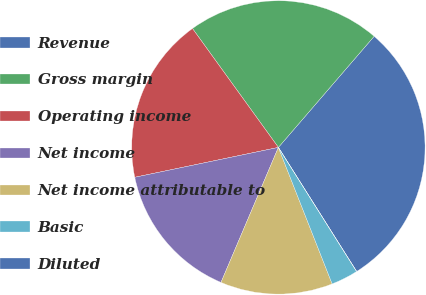Convert chart to OTSL. <chart><loc_0><loc_0><loc_500><loc_500><pie_chart><fcel>Revenue<fcel>Gross margin<fcel>Operating income<fcel>Net income<fcel>Net income attributable to<fcel>Basic<fcel>Diluted<nl><fcel>29.72%<fcel>21.28%<fcel>18.31%<fcel>15.34%<fcel>12.37%<fcel>2.98%<fcel>0.01%<nl></chart> 